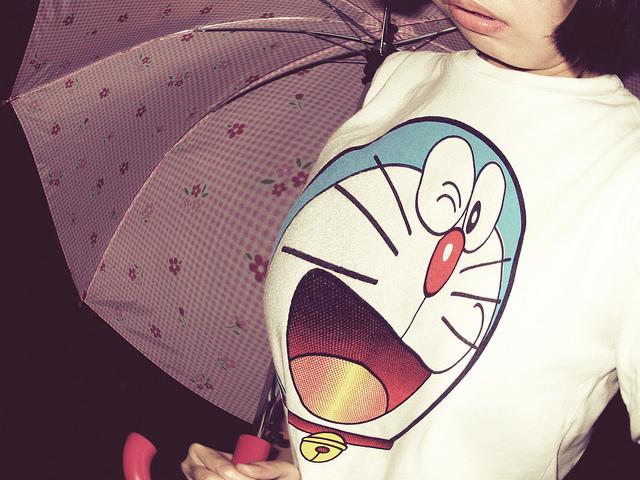What is the woman holding?
Give a very brief answer. Umbrella. What popular character is displayed on the front of this woman's T-shirt?
Short answer required. Cat. What is the color of the handle of the umbrella?
Be succinct. Pink. 